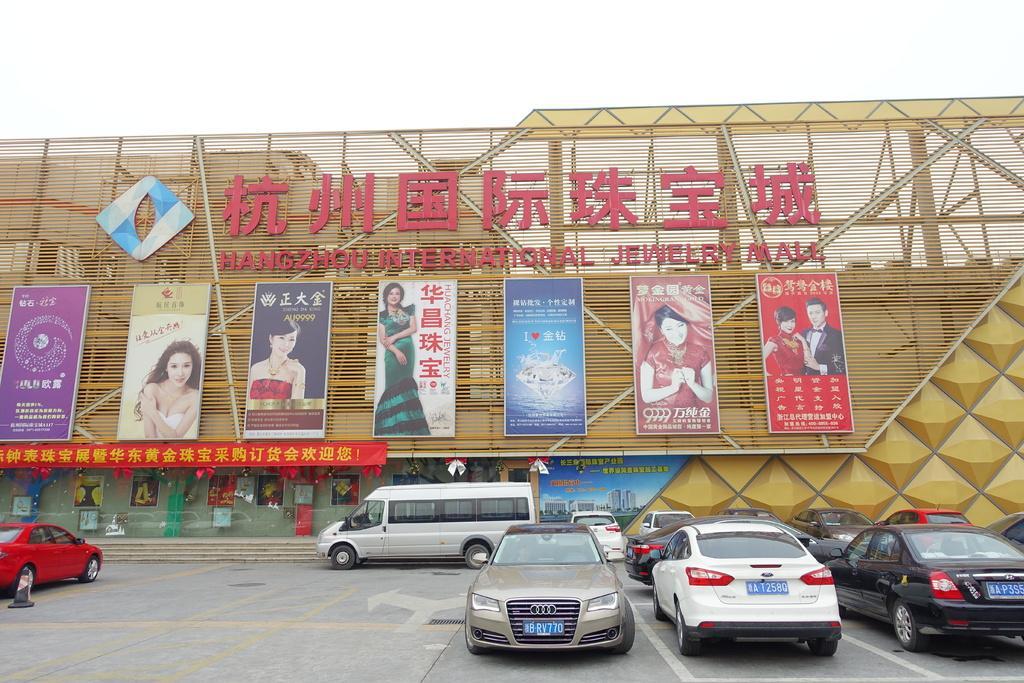Could you give a brief overview of what you see in this image? In this image, we can see a building. Here we can see few hoardings, banners, posters. At the bottom, we can see vehicles are parked on the parking slot. Left side of the image, we can see a traffic cone. Here we can see few stairs. 